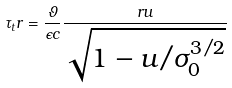<formula> <loc_0><loc_0><loc_500><loc_500>\tau _ { t } r = \frac { \vartheta } { \epsilon c } \frac { r u } { \sqrt { 1 - u / \sigma _ { 0 } ^ { 3 / 2 } } }</formula> 